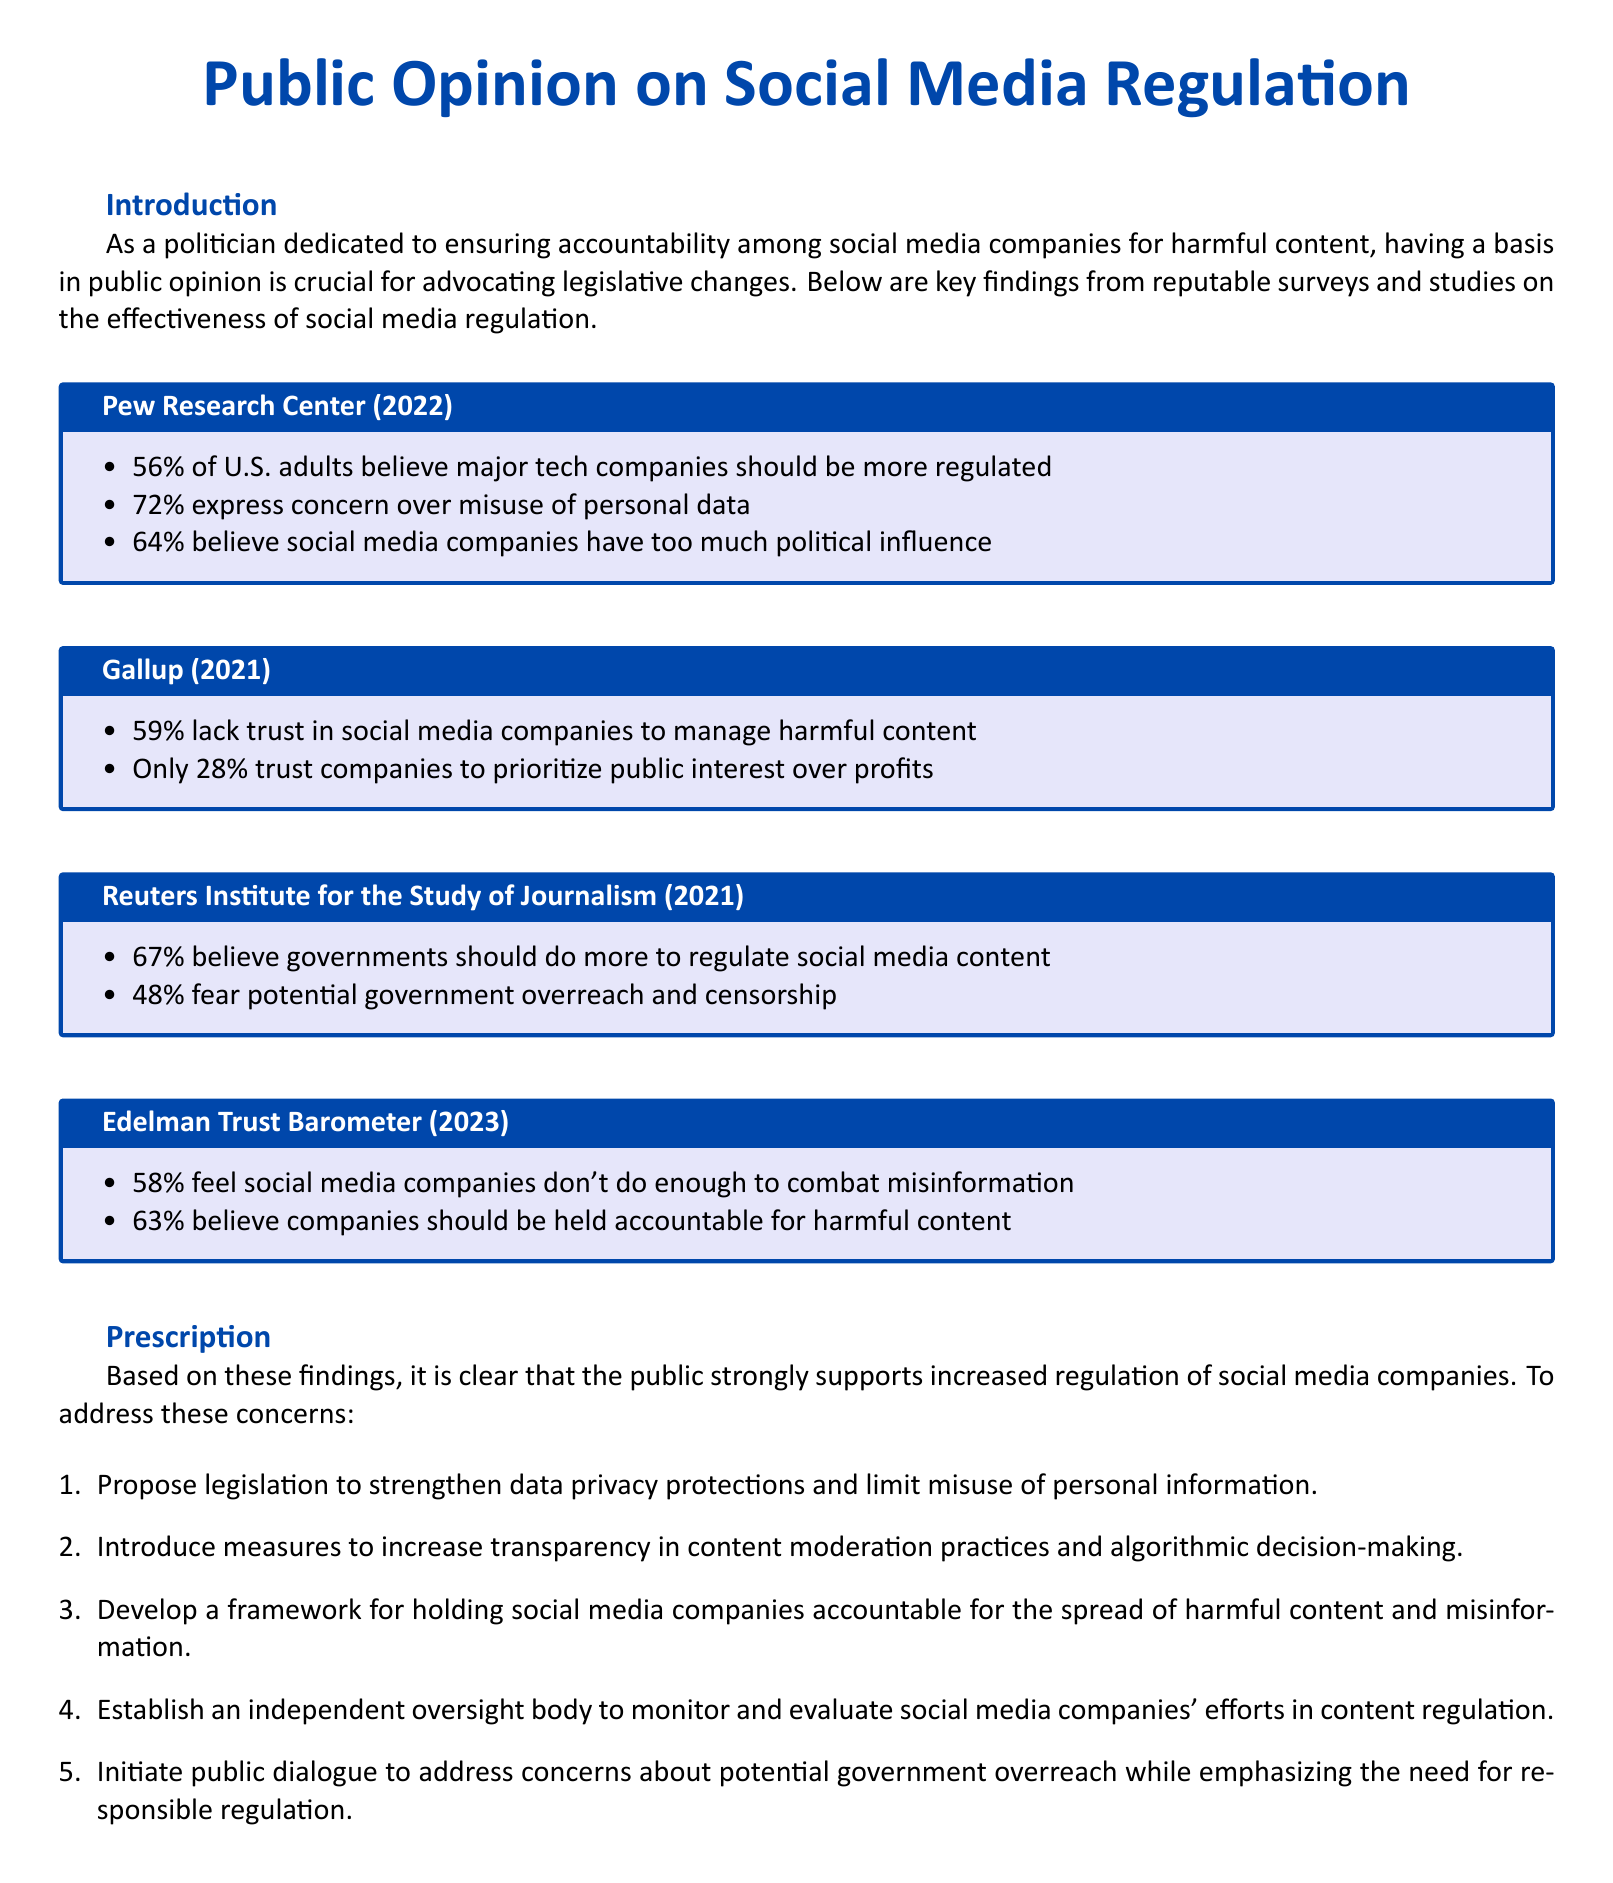What percentage of U.S. adults believe tech companies should be more regulated? The document states that 56% of U.S. adults believe major tech companies should be more regulated.
Answer: 56% What concerns do 72% of individuals express regarding social media? According to the document, 72% express concern over misuse of personal data.
Answer: Misuse of personal data What percentage of people lack trust in social media companies to manage harmful content? The document reports that 59% lack trust in social media companies to manage harmful content.
Answer: 59% What is the percentage of individuals who believe governments should do more to regulate social media? The document indicates that 67% believe governments should do more to regulate social media content.
Answer: 67% How many people fear government overreach and censorship? The document mentions that 48% fear potential government overreach and censorship.
Answer: 48% What action does the document suggest regarding holding social media companies accountable? The document prescribes developing a framework for holding social media companies accountable for harmful content.
Answer: Develop a framework What year did the Edelman Trust Barometer release its survey findings? The document references the Edelman Trust Barometer findings from 2023.
Answer: 2023 What is one proposed legislation area to strengthen protections? According to the document, one proposed action is to strengthen data privacy protections.
Answer: Data privacy protections How many people believe social media companies should be held accountable for harmful content? The document states that 63% believe companies should be held accountable for harmful content.
Answer: 63% 